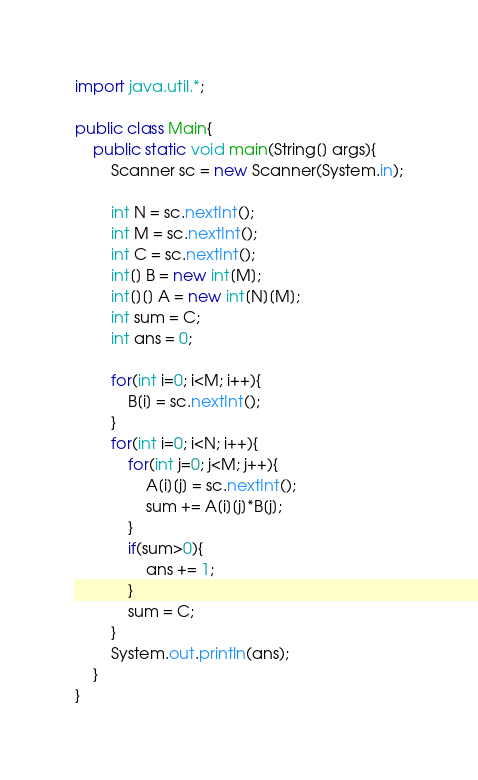Convert code to text. <code><loc_0><loc_0><loc_500><loc_500><_Java_>import java.util.*;

public class Main{
    public static void main(String[] args){
        Scanner sc = new Scanner(System.in);

        int N = sc.nextInt();
        int M = sc.nextInt();
        int C = sc.nextInt();
        int[] B = new int[M];
        int[][] A = new int[N][M];
        int sum = C;
        int ans = 0;

        for(int i=0; i<M; i++){
            B[i] = sc.nextInt();
        }
        for(int i=0; i<N; i++){
            for(int j=0; j<M; j++){
                A[i][j] = sc.nextInt();
                sum += A[i][j]*B[j];
            }
            if(sum>0){
                ans += 1;
            }
            sum = C;
        }
        System.out.println(ans);
    }
}</code> 